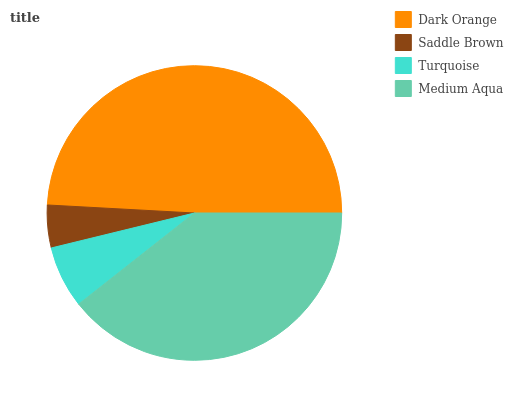Is Saddle Brown the minimum?
Answer yes or no. Yes. Is Dark Orange the maximum?
Answer yes or no. Yes. Is Turquoise the minimum?
Answer yes or no. No. Is Turquoise the maximum?
Answer yes or no. No. Is Turquoise greater than Saddle Brown?
Answer yes or no. Yes. Is Saddle Brown less than Turquoise?
Answer yes or no. Yes. Is Saddle Brown greater than Turquoise?
Answer yes or no. No. Is Turquoise less than Saddle Brown?
Answer yes or no. No. Is Medium Aqua the high median?
Answer yes or no. Yes. Is Turquoise the low median?
Answer yes or no. Yes. Is Saddle Brown the high median?
Answer yes or no. No. Is Medium Aqua the low median?
Answer yes or no. No. 